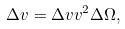<formula> <loc_0><loc_0><loc_500><loc_500>\Delta { v } = \Delta v v ^ { 2 } \Delta \Omega ,</formula> 